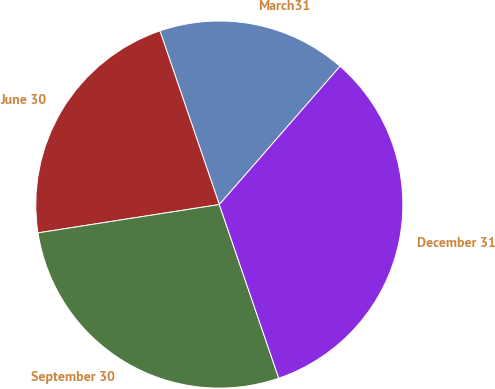<chart> <loc_0><loc_0><loc_500><loc_500><pie_chart><fcel>March31<fcel>June 30<fcel>September 30<fcel>December 31<nl><fcel>16.67%<fcel>22.22%<fcel>27.78%<fcel>33.33%<nl></chart> 